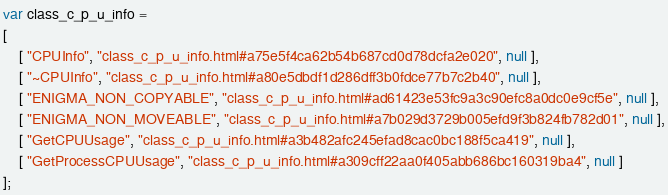Convert code to text. <code><loc_0><loc_0><loc_500><loc_500><_JavaScript_>var class_c_p_u_info =
[
    [ "CPUInfo", "class_c_p_u_info.html#a75e5f4ca62b54b687cd0d78dcfa2e020", null ],
    [ "~CPUInfo", "class_c_p_u_info.html#a80e5dbdf1d286dff3b0fdce77b7c2b40", null ],
    [ "ENIGMA_NON_COPYABLE", "class_c_p_u_info.html#ad61423e53fc9a3c90efc8a0dc0e9cf5e", null ],
    [ "ENIGMA_NON_MOVEABLE", "class_c_p_u_info.html#a7b029d3729b005efd9f3b824fb782d01", null ],
    [ "GetCPUUsage", "class_c_p_u_info.html#a3b482afc245efad8cac0bc188f5ca419", null ],
    [ "GetProcessCPUUsage", "class_c_p_u_info.html#a309cff22aa0f405abb686bc160319ba4", null ]
];</code> 